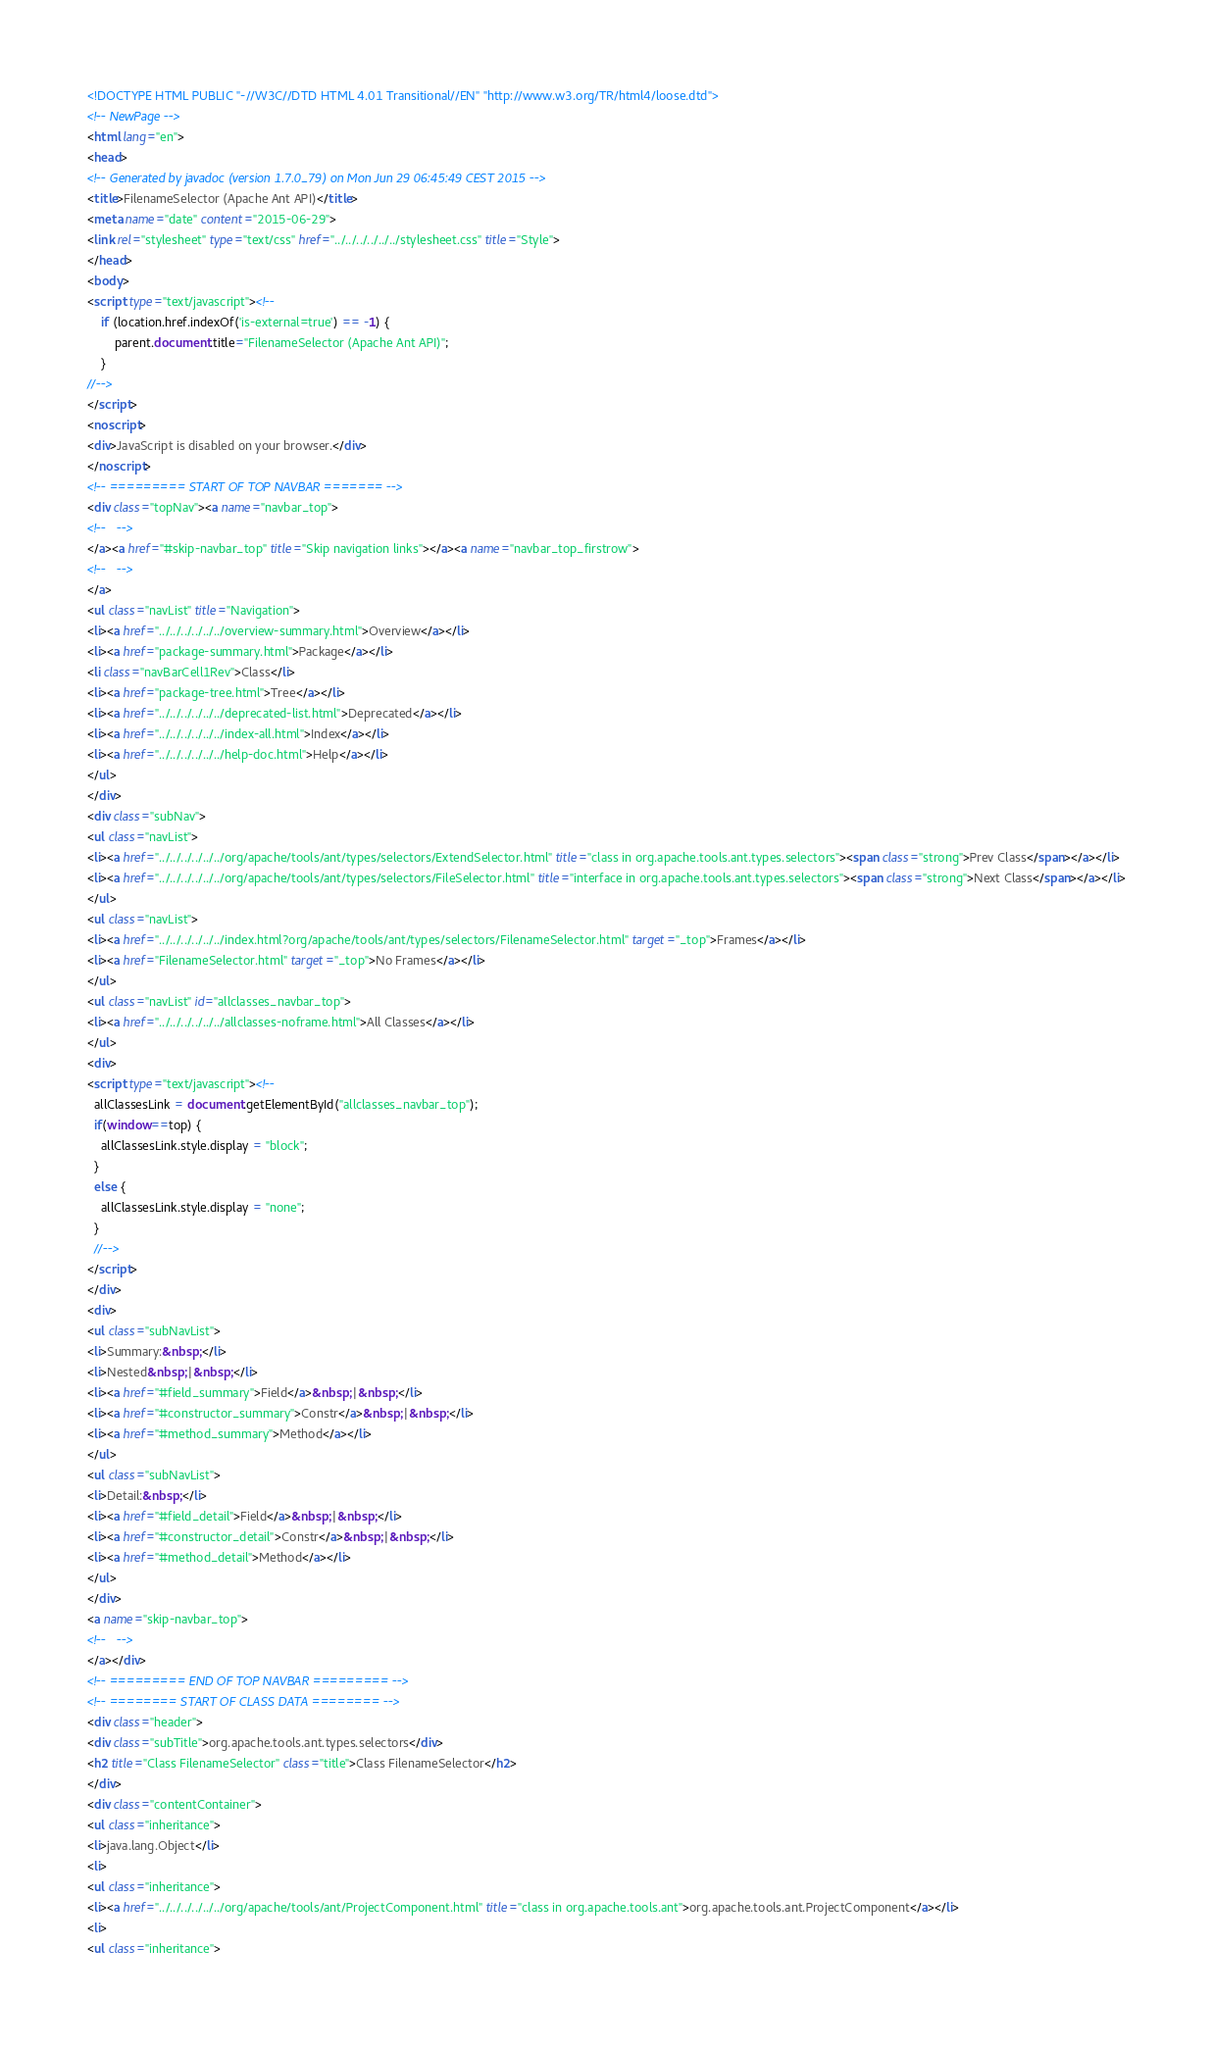<code> <loc_0><loc_0><loc_500><loc_500><_HTML_><!DOCTYPE HTML PUBLIC "-//W3C//DTD HTML 4.01 Transitional//EN" "http://www.w3.org/TR/html4/loose.dtd">
<!-- NewPage -->
<html lang="en">
<head>
<!-- Generated by javadoc (version 1.7.0_79) on Mon Jun 29 06:45:49 CEST 2015 -->
<title>FilenameSelector (Apache Ant API)</title>
<meta name="date" content="2015-06-29">
<link rel="stylesheet" type="text/css" href="../../../../../../stylesheet.css" title="Style">
</head>
<body>
<script type="text/javascript"><!--
    if (location.href.indexOf('is-external=true') == -1) {
        parent.document.title="FilenameSelector (Apache Ant API)";
    }
//-->
</script>
<noscript>
<div>JavaScript is disabled on your browser.</div>
</noscript>
<!-- ========= START OF TOP NAVBAR ======= -->
<div class="topNav"><a name="navbar_top">
<!--   -->
</a><a href="#skip-navbar_top" title="Skip navigation links"></a><a name="navbar_top_firstrow">
<!--   -->
</a>
<ul class="navList" title="Navigation">
<li><a href="../../../../../../overview-summary.html">Overview</a></li>
<li><a href="package-summary.html">Package</a></li>
<li class="navBarCell1Rev">Class</li>
<li><a href="package-tree.html">Tree</a></li>
<li><a href="../../../../../../deprecated-list.html">Deprecated</a></li>
<li><a href="../../../../../../index-all.html">Index</a></li>
<li><a href="../../../../../../help-doc.html">Help</a></li>
</ul>
</div>
<div class="subNav">
<ul class="navList">
<li><a href="../../../../../../org/apache/tools/ant/types/selectors/ExtendSelector.html" title="class in org.apache.tools.ant.types.selectors"><span class="strong">Prev Class</span></a></li>
<li><a href="../../../../../../org/apache/tools/ant/types/selectors/FileSelector.html" title="interface in org.apache.tools.ant.types.selectors"><span class="strong">Next Class</span></a></li>
</ul>
<ul class="navList">
<li><a href="../../../../../../index.html?org/apache/tools/ant/types/selectors/FilenameSelector.html" target="_top">Frames</a></li>
<li><a href="FilenameSelector.html" target="_top">No Frames</a></li>
</ul>
<ul class="navList" id="allclasses_navbar_top">
<li><a href="../../../../../../allclasses-noframe.html">All Classes</a></li>
</ul>
<div>
<script type="text/javascript"><!--
  allClassesLink = document.getElementById("allclasses_navbar_top");
  if(window==top) {
    allClassesLink.style.display = "block";
  }
  else {
    allClassesLink.style.display = "none";
  }
  //-->
</script>
</div>
<div>
<ul class="subNavList">
<li>Summary:&nbsp;</li>
<li>Nested&nbsp;|&nbsp;</li>
<li><a href="#field_summary">Field</a>&nbsp;|&nbsp;</li>
<li><a href="#constructor_summary">Constr</a>&nbsp;|&nbsp;</li>
<li><a href="#method_summary">Method</a></li>
</ul>
<ul class="subNavList">
<li>Detail:&nbsp;</li>
<li><a href="#field_detail">Field</a>&nbsp;|&nbsp;</li>
<li><a href="#constructor_detail">Constr</a>&nbsp;|&nbsp;</li>
<li><a href="#method_detail">Method</a></li>
</ul>
</div>
<a name="skip-navbar_top">
<!--   -->
</a></div>
<!-- ========= END OF TOP NAVBAR ========= -->
<!-- ======== START OF CLASS DATA ======== -->
<div class="header">
<div class="subTitle">org.apache.tools.ant.types.selectors</div>
<h2 title="Class FilenameSelector" class="title">Class FilenameSelector</h2>
</div>
<div class="contentContainer">
<ul class="inheritance">
<li>java.lang.Object</li>
<li>
<ul class="inheritance">
<li><a href="../../../../../../org/apache/tools/ant/ProjectComponent.html" title="class in org.apache.tools.ant">org.apache.tools.ant.ProjectComponent</a></li>
<li>
<ul class="inheritance"></code> 